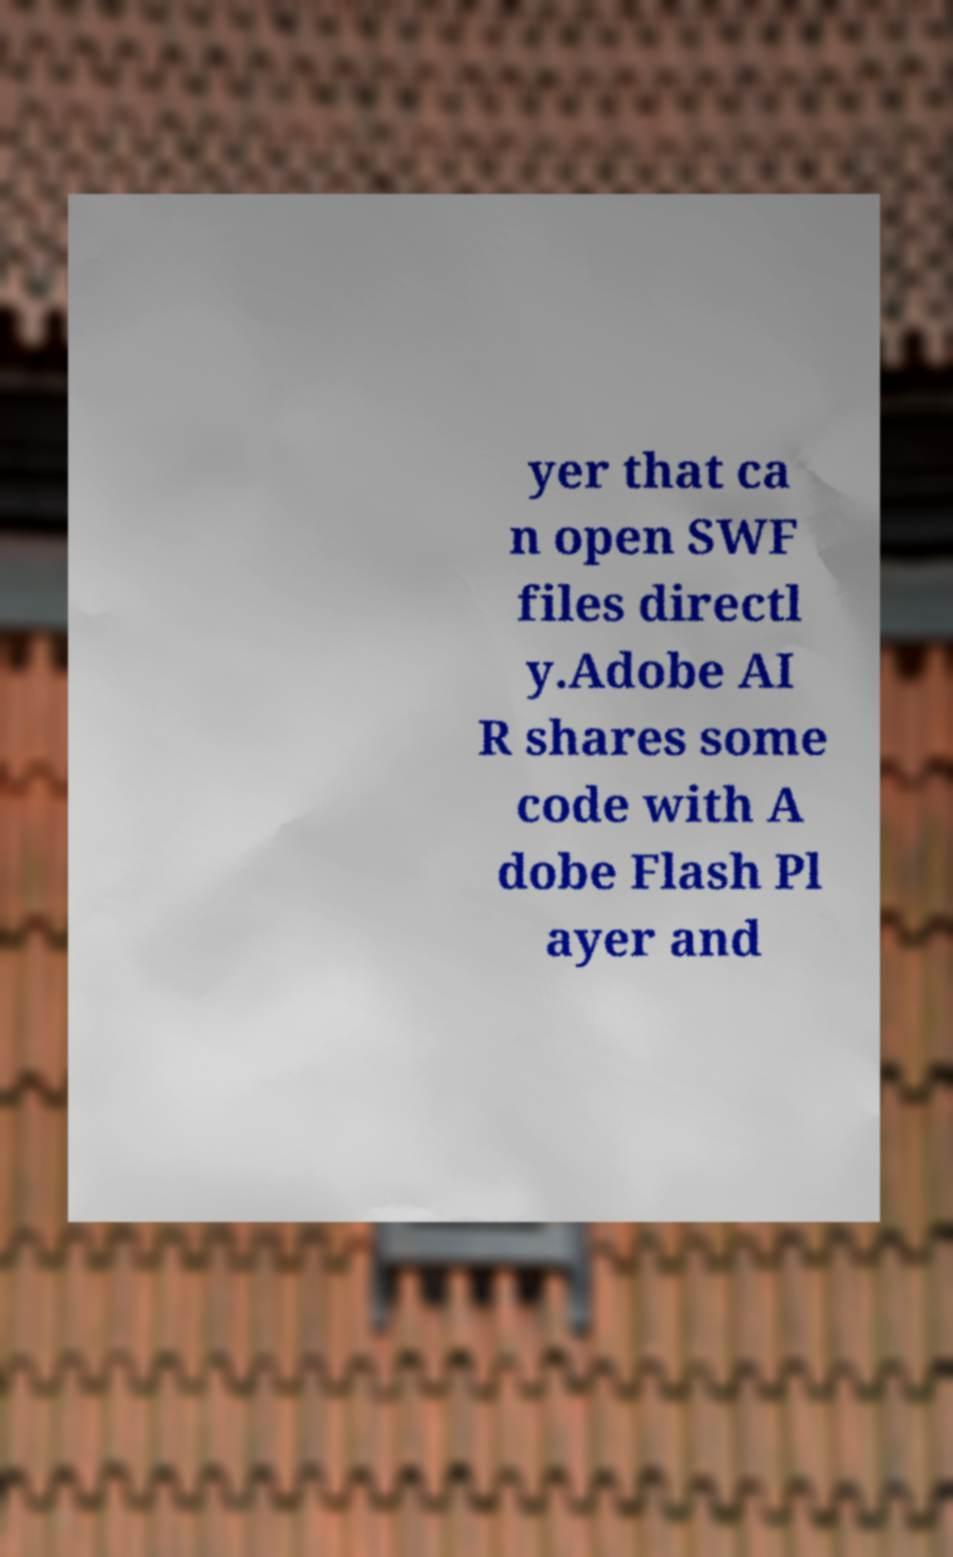I need the written content from this picture converted into text. Can you do that? yer that ca n open SWF files directl y.Adobe AI R shares some code with A dobe Flash Pl ayer and 